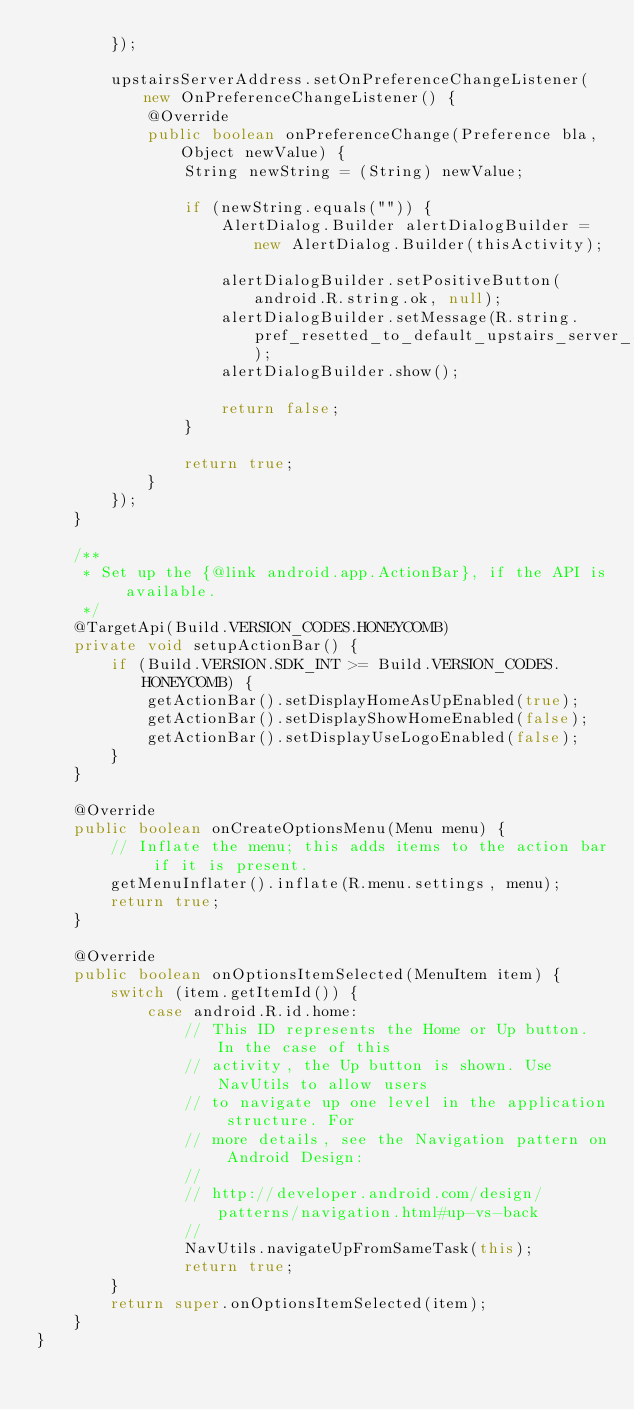<code> <loc_0><loc_0><loc_500><loc_500><_Java_>        });

        upstairsServerAddress.setOnPreferenceChangeListener(new OnPreferenceChangeListener() {
            @Override
            public boolean onPreferenceChange(Preference bla, Object newValue) {
                String newString = (String) newValue;

                if (newString.equals("")) {
                    AlertDialog.Builder alertDialogBuilder = new AlertDialog.Builder(thisActivity);

                    alertDialogBuilder.setPositiveButton(android.R.string.ok, null);
                    alertDialogBuilder.setMessage(R.string.pref_resetted_to_default_upstairs_server_address);
                    alertDialogBuilder.show();

                    return false;
                }

                return true;
            }
        });
    }
    
    /**
	 * Set up the {@link android.app.ActionBar}, if the API is available.
	 */
	@TargetApi(Build.VERSION_CODES.HONEYCOMB)
	private void setupActionBar() {
		if (Build.VERSION.SDK_INT >= Build.VERSION_CODES.HONEYCOMB) {
			getActionBar().setDisplayHomeAsUpEnabled(true);
			getActionBar().setDisplayShowHomeEnabled(false);
			getActionBar().setDisplayUseLogoEnabled(false);
		}
	}
	
	@Override
	public boolean onCreateOptionsMenu(Menu menu) {
		// Inflate the menu; this adds items to the action bar if it is present.
		getMenuInflater().inflate(R.menu.settings, menu);
		return true;
	}
	
	@Override
	public boolean onOptionsItemSelected(MenuItem item) {
		switch (item.getItemId()) {
			case android.R.id.home:
				// This ID represents the Home or Up button. In the case of this
				// activity, the Up button is shown. Use NavUtils to allow users
				// to navigate up one level in the application structure. For
				// more details, see the Navigation pattern on Android Design:
				//
				// http://developer.android.com/design/patterns/navigation.html#up-vs-back
				//
				NavUtils.navigateUpFromSameTask(this);
				return true;
		}
		return super.onOptionsItemSelected(item);
	}
}</code> 